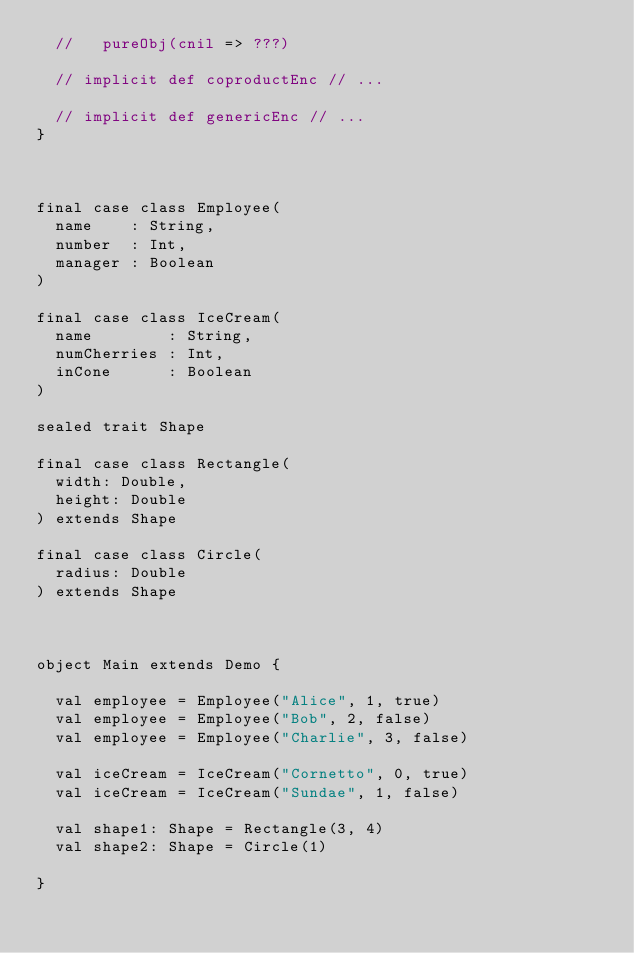Convert code to text. <code><loc_0><loc_0><loc_500><loc_500><_Scala_>  //   pureObj(cnil => ???)

  // implicit def coproductEnc // ...

  // implicit def genericEnc // ...
}



final case class Employee(
  name    : String,
  number  : Int,
  manager : Boolean
)

final case class IceCream(
  name        : String,
  numCherries : Int,
  inCone      : Boolean
)

sealed trait Shape

final case class Rectangle(
  width: Double,
  height: Double
) extends Shape

final case class Circle(
  radius: Double
) extends Shape



object Main extends Demo {

  val employee = Employee("Alice", 1, true)
  val employee = Employee("Bob", 2, false)
  val employee = Employee("Charlie", 3, false)

  val iceCream = IceCream("Cornetto", 0, true)
  val iceCream = IceCream("Sundae", 1, false)

  val shape1: Shape = Rectangle(3, 4)
  val shape2: Shape = Circle(1)

}


</code> 